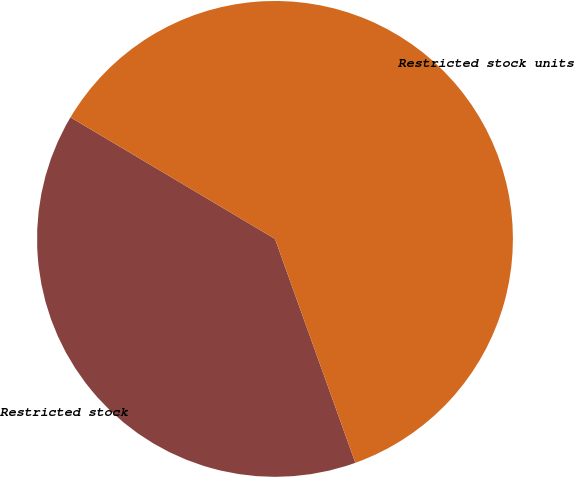<chart> <loc_0><loc_0><loc_500><loc_500><pie_chart><fcel>Restricted stock<fcel>Restricted stock units<nl><fcel>39.02%<fcel>60.98%<nl></chart> 